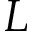Convert formula to latex. <formula><loc_0><loc_0><loc_500><loc_500>L</formula> 